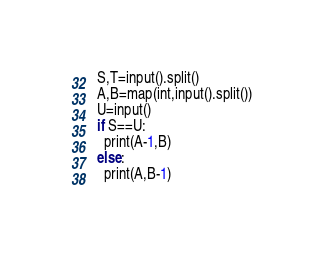<code> <loc_0><loc_0><loc_500><loc_500><_Python_>S,T=input().split()
A,B=map(int,input().split())
U=input()
if S==U:
  print(A-1,B)
else:
  print(A,B-1)</code> 